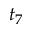<formula> <loc_0><loc_0><loc_500><loc_500>t _ { 7 }</formula> 